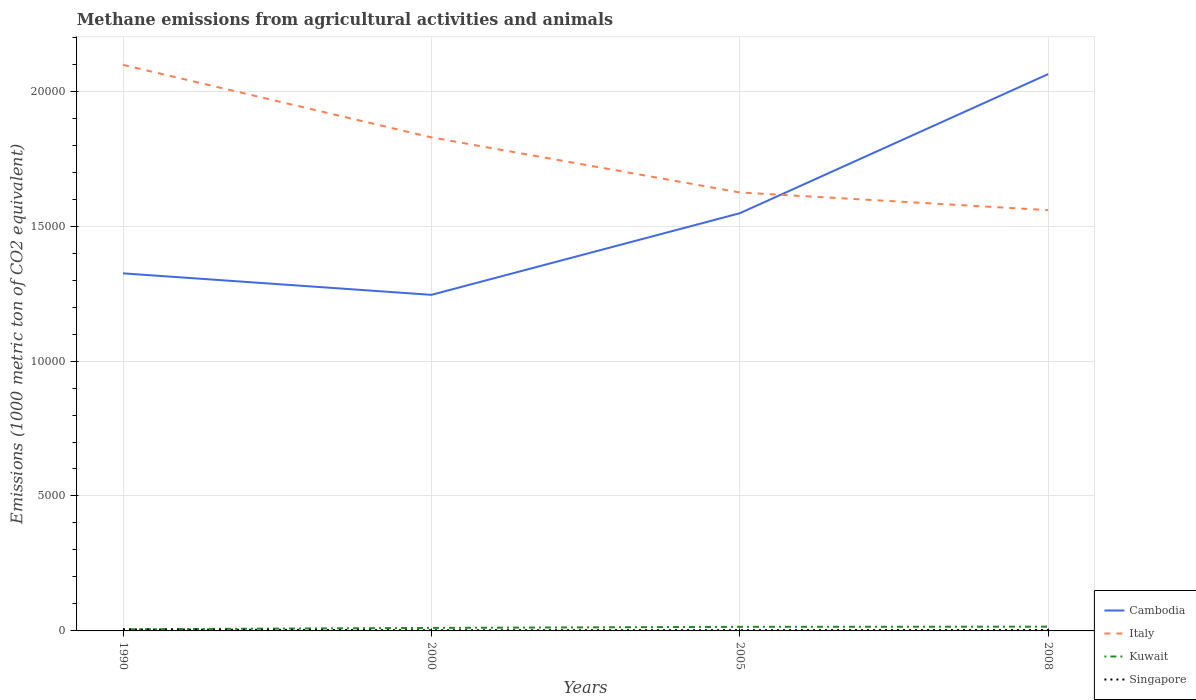How many different coloured lines are there?
Provide a succinct answer. 4. Is the number of lines equal to the number of legend labels?
Provide a succinct answer. Yes. Across all years, what is the maximum amount of methane emitted in Cambodia?
Give a very brief answer. 1.25e+04. What is the total amount of methane emitted in Kuwait in the graph?
Your answer should be very brief. -46.4. What is the difference between the highest and the second highest amount of methane emitted in Italy?
Your answer should be very brief. 5383.9. What is the difference between the highest and the lowest amount of methane emitted in Italy?
Give a very brief answer. 2. Is the amount of methane emitted in Cambodia strictly greater than the amount of methane emitted in Italy over the years?
Offer a very short reply. No. How many lines are there?
Provide a succinct answer. 4. How many years are there in the graph?
Your answer should be compact. 4. Does the graph contain any zero values?
Your answer should be compact. No. How many legend labels are there?
Provide a succinct answer. 4. How are the legend labels stacked?
Keep it short and to the point. Vertical. What is the title of the graph?
Ensure brevity in your answer.  Methane emissions from agricultural activities and animals. Does "Antigua and Barbuda" appear as one of the legend labels in the graph?
Make the answer very short. No. What is the label or title of the X-axis?
Your response must be concise. Years. What is the label or title of the Y-axis?
Offer a very short reply. Emissions (1000 metric ton of CO2 equivalent). What is the Emissions (1000 metric ton of CO2 equivalent) in Cambodia in 1990?
Your answer should be compact. 1.32e+04. What is the Emissions (1000 metric ton of CO2 equivalent) of Italy in 1990?
Keep it short and to the point. 2.10e+04. What is the Emissions (1000 metric ton of CO2 equivalent) of Kuwait in 1990?
Offer a terse response. 60.5. What is the Emissions (1000 metric ton of CO2 equivalent) in Singapore in 1990?
Provide a short and direct response. 55.6. What is the Emissions (1000 metric ton of CO2 equivalent) in Cambodia in 2000?
Your answer should be very brief. 1.25e+04. What is the Emissions (1000 metric ton of CO2 equivalent) in Italy in 2000?
Your answer should be compact. 1.83e+04. What is the Emissions (1000 metric ton of CO2 equivalent) in Kuwait in 2000?
Make the answer very short. 111.6. What is the Emissions (1000 metric ton of CO2 equivalent) in Singapore in 2000?
Keep it short and to the point. 24.4. What is the Emissions (1000 metric ton of CO2 equivalent) in Cambodia in 2005?
Give a very brief answer. 1.55e+04. What is the Emissions (1000 metric ton of CO2 equivalent) of Italy in 2005?
Ensure brevity in your answer.  1.62e+04. What is the Emissions (1000 metric ton of CO2 equivalent) in Kuwait in 2005?
Your response must be concise. 151.9. What is the Emissions (1000 metric ton of CO2 equivalent) of Singapore in 2005?
Your answer should be compact. 28.4. What is the Emissions (1000 metric ton of CO2 equivalent) in Cambodia in 2008?
Your answer should be compact. 2.06e+04. What is the Emissions (1000 metric ton of CO2 equivalent) of Italy in 2008?
Offer a very short reply. 1.56e+04. What is the Emissions (1000 metric ton of CO2 equivalent) of Kuwait in 2008?
Give a very brief answer. 158. What is the Emissions (1000 metric ton of CO2 equivalent) of Singapore in 2008?
Keep it short and to the point. 32.8. Across all years, what is the maximum Emissions (1000 metric ton of CO2 equivalent) of Cambodia?
Keep it short and to the point. 2.06e+04. Across all years, what is the maximum Emissions (1000 metric ton of CO2 equivalent) of Italy?
Your answer should be very brief. 2.10e+04. Across all years, what is the maximum Emissions (1000 metric ton of CO2 equivalent) of Kuwait?
Provide a short and direct response. 158. Across all years, what is the maximum Emissions (1000 metric ton of CO2 equivalent) of Singapore?
Keep it short and to the point. 55.6. Across all years, what is the minimum Emissions (1000 metric ton of CO2 equivalent) of Cambodia?
Offer a terse response. 1.25e+04. Across all years, what is the minimum Emissions (1000 metric ton of CO2 equivalent) of Italy?
Give a very brief answer. 1.56e+04. Across all years, what is the minimum Emissions (1000 metric ton of CO2 equivalent) of Kuwait?
Offer a very short reply. 60.5. Across all years, what is the minimum Emissions (1000 metric ton of CO2 equivalent) of Singapore?
Your response must be concise. 24.4. What is the total Emissions (1000 metric ton of CO2 equivalent) in Cambodia in the graph?
Your response must be concise. 6.18e+04. What is the total Emissions (1000 metric ton of CO2 equivalent) in Italy in the graph?
Your answer should be very brief. 7.11e+04. What is the total Emissions (1000 metric ton of CO2 equivalent) in Kuwait in the graph?
Your response must be concise. 482. What is the total Emissions (1000 metric ton of CO2 equivalent) of Singapore in the graph?
Make the answer very short. 141.2. What is the difference between the Emissions (1000 metric ton of CO2 equivalent) of Cambodia in 1990 and that in 2000?
Your answer should be compact. 796.5. What is the difference between the Emissions (1000 metric ton of CO2 equivalent) in Italy in 1990 and that in 2000?
Offer a terse response. 2687.3. What is the difference between the Emissions (1000 metric ton of CO2 equivalent) of Kuwait in 1990 and that in 2000?
Ensure brevity in your answer.  -51.1. What is the difference between the Emissions (1000 metric ton of CO2 equivalent) of Singapore in 1990 and that in 2000?
Your answer should be very brief. 31.2. What is the difference between the Emissions (1000 metric ton of CO2 equivalent) of Cambodia in 1990 and that in 2005?
Provide a succinct answer. -2227.1. What is the difference between the Emissions (1000 metric ton of CO2 equivalent) of Italy in 1990 and that in 2005?
Offer a very short reply. 4727.8. What is the difference between the Emissions (1000 metric ton of CO2 equivalent) in Kuwait in 1990 and that in 2005?
Your answer should be compact. -91.4. What is the difference between the Emissions (1000 metric ton of CO2 equivalent) of Singapore in 1990 and that in 2005?
Keep it short and to the point. 27.2. What is the difference between the Emissions (1000 metric ton of CO2 equivalent) of Cambodia in 1990 and that in 2008?
Provide a short and direct response. -7382.4. What is the difference between the Emissions (1000 metric ton of CO2 equivalent) in Italy in 1990 and that in 2008?
Your answer should be compact. 5383.9. What is the difference between the Emissions (1000 metric ton of CO2 equivalent) of Kuwait in 1990 and that in 2008?
Offer a terse response. -97.5. What is the difference between the Emissions (1000 metric ton of CO2 equivalent) of Singapore in 1990 and that in 2008?
Your response must be concise. 22.8. What is the difference between the Emissions (1000 metric ton of CO2 equivalent) in Cambodia in 2000 and that in 2005?
Make the answer very short. -3023.6. What is the difference between the Emissions (1000 metric ton of CO2 equivalent) of Italy in 2000 and that in 2005?
Give a very brief answer. 2040.5. What is the difference between the Emissions (1000 metric ton of CO2 equivalent) in Kuwait in 2000 and that in 2005?
Give a very brief answer. -40.3. What is the difference between the Emissions (1000 metric ton of CO2 equivalent) in Singapore in 2000 and that in 2005?
Make the answer very short. -4. What is the difference between the Emissions (1000 metric ton of CO2 equivalent) of Cambodia in 2000 and that in 2008?
Give a very brief answer. -8178.9. What is the difference between the Emissions (1000 metric ton of CO2 equivalent) of Italy in 2000 and that in 2008?
Your answer should be compact. 2696.6. What is the difference between the Emissions (1000 metric ton of CO2 equivalent) of Kuwait in 2000 and that in 2008?
Make the answer very short. -46.4. What is the difference between the Emissions (1000 metric ton of CO2 equivalent) in Cambodia in 2005 and that in 2008?
Ensure brevity in your answer.  -5155.3. What is the difference between the Emissions (1000 metric ton of CO2 equivalent) in Italy in 2005 and that in 2008?
Offer a very short reply. 656.1. What is the difference between the Emissions (1000 metric ton of CO2 equivalent) in Cambodia in 1990 and the Emissions (1000 metric ton of CO2 equivalent) in Italy in 2000?
Keep it short and to the point. -5038.3. What is the difference between the Emissions (1000 metric ton of CO2 equivalent) of Cambodia in 1990 and the Emissions (1000 metric ton of CO2 equivalent) of Kuwait in 2000?
Offer a terse response. 1.31e+04. What is the difference between the Emissions (1000 metric ton of CO2 equivalent) in Cambodia in 1990 and the Emissions (1000 metric ton of CO2 equivalent) in Singapore in 2000?
Give a very brief answer. 1.32e+04. What is the difference between the Emissions (1000 metric ton of CO2 equivalent) in Italy in 1990 and the Emissions (1000 metric ton of CO2 equivalent) in Kuwait in 2000?
Your answer should be compact. 2.09e+04. What is the difference between the Emissions (1000 metric ton of CO2 equivalent) of Italy in 1990 and the Emissions (1000 metric ton of CO2 equivalent) of Singapore in 2000?
Give a very brief answer. 2.10e+04. What is the difference between the Emissions (1000 metric ton of CO2 equivalent) of Kuwait in 1990 and the Emissions (1000 metric ton of CO2 equivalent) of Singapore in 2000?
Offer a very short reply. 36.1. What is the difference between the Emissions (1000 metric ton of CO2 equivalent) of Cambodia in 1990 and the Emissions (1000 metric ton of CO2 equivalent) of Italy in 2005?
Your answer should be very brief. -2997.8. What is the difference between the Emissions (1000 metric ton of CO2 equivalent) in Cambodia in 1990 and the Emissions (1000 metric ton of CO2 equivalent) in Kuwait in 2005?
Give a very brief answer. 1.31e+04. What is the difference between the Emissions (1000 metric ton of CO2 equivalent) in Cambodia in 1990 and the Emissions (1000 metric ton of CO2 equivalent) in Singapore in 2005?
Your answer should be very brief. 1.32e+04. What is the difference between the Emissions (1000 metric ton of CO2 equivalent) in Italy in 1990 and the Emissions (1000 metric ton of CO2 equivalent) in Kuwait in 2005?
Offer a very short reply. 2.08e+04. What is the difference between the Emissions (1000 metric ton of CO2 equivalent) in Italy in 1990 and the Emissions (1000 metric ton of CO2 equivalent) in Singapore in 2005?
Offer a very short reply. 2.09e+04. What is the difference between the Emissions (1000 metric ton of CO2 equivalent) of Kuwait in 1990 and the Emissions (1000 metric ton of CO2 equivalent) of Singapore in 2005?
Offer a terse response. 32.1. What is the difference between the Emissions (1000 metric ton of CO2 equivalent) of Cambodia in 1990 and the Emissions (1000 metric ton of CO2 equivalent) of Italy in 2008?
Your answer should be very brief. -2341.7. What is the difference between the Emissions (1000 metric ton of CO2 equivalent) in Cambodia in 1990 and the Emissions (1000 metric ton of CO2 equivalent) in Kuwait in 2008?
Provide a short and direct response. 1.31e+04. What is the difference between the Emissions (1000 metric ton of CO2 equivalent) in Cambodia in 1990 and the Emissions (1000 metric ton of CO2 equivalent) in Singapore in 2008?
Provide a short and direct response. 1.32e+04. What is the difference between the Emissions (1000 metric ton of CO2 equivalent) of Italy in 1990 and the Emissions (1000 metric ton of CO2 equivalent) of Kuwait in 2008?
Your answer should be compact. 2.08e+04. What is the difference between the Emissions (1000 metric ton of CO2 equivalent) in Italy in 1990 and the Emissions (1000 metric ton of CO2 equivalent) in Singapore in 2008?
Your answer should be compact. 2.09e+04. What is the difference between the Emissions (1000 metric ton of CO2 equivalent) in Kuwait in 1990 and the Emissions (1000 metric ton of CO2 equivalent) in Singapore in 2008?
Your response must be concise. 27.7. What is the difference between the Emissions (1000 metric ton of CO2 equivalent) in Cambodia in 2000 and the Emissions (1000 metric ton of CO2 equivalent) in Italy in 2005?
Provide a short and direct response. -3794.3. What is the difference between the Emissions (1000 metric ton of CO2 equivalent) in Cambodia in 2000 and the Emissions (1000 metric ton of CO2 equivalent) in Kuwait in 2005?
Provide a short and direct response. 1.23e+04. What is the difference between the Emissions (1000 metric ton of CO2 equivalent) in Cambodia in 2000 and the Emissions (1000 metric ton of CO2 equivalent) in Singapore in 2005?
Offer a very short reply. 1.24e+04. What is the difference between the Emissions (1000 metric ton of CO2 equivalent) of Italy in 2000 and the Emissions (1000 metric ton of CO2 equivalent) of Kuwait in 2005?
Ensure brevity in your answer.  1.81e+04. What is the difference between the Emissions (1000 metric ton of CO2 equivalent) in Italy in 2000 and the Emissions (1000 metric ton of CO2 equivalent) in Singapore in 2005?
Ensure brevity in your answer.  1.83e+04. What is the difference between the Emissions (1000 metric ton of CO2 equivalent) in Kuwait in 2000 and the Emissions (1000 metric ton of CO2 equivalent) in Singapore in 2005?
Give a very brief answer. 83.2. What is the difference between the Emissions (1000 metric ton of CO2 equivalent) of Cambodia in 2000 and the Emissions (1000 metric ton of CO2 equivalent) of Italy in 2008?
Provide a short and direct response. -3138.2. What is the difference between the Emissions (1000 metric ton of CO2 equivalent) of Cambodia in 2000 and the Emissions (1000 metric ton of CO2 equivalent) of Kuwait in 2008?
Your response must be concise. 1.23e+04. What is the difference between the Emissions (1000 metric ton of CO2 equivalent) of Cambodia in 2000 and the Emissions (1000 metric ton of CO2 equivalent) of Singapore in 2008?
Provide a succinct answer. 1.24e+04. What is the difference between the Emissions (1000 metric ton of CO2 equivalent) in Italy in 2000 and the Emissions (1000 metric ton of CO2 equivalent) in Kuwait in 2008?
Provide a succinct answer. 1.81e+04. What is the difference between the Emissions (1000 metric ton of CO2 equivalent) of Italy in 2000 and the Emissions (1000 metric ton of CO2 equivalent) of Singapore in 2008?
Offer a very short reply. 1.83e+04. What is the difference between the Emissions (1000 metric ton of CO2 equivalent) of Kuwait in 2000 and the Emissions (1000 metric ton of CO2 equivalent) of Singapore in 2008?
Make the answer very short. 78.8. What is the difference between the Emissions (1000 metric ton of CO2 equivalent) of Cambodia in 2005 and the Emissions (1000 metric ton of CO2 equivalent) of Italy in 2008?
Give a very brief answer. -114.6. What is the difference between the Emissions (1000 metric ton of CO2 equivalent) in Cambodia in 2005 and the Emissions (1000 metric ton of CO2 equivalent) in Kuwait in 2008?
Offer a very short reply. 1.53e+04. What is the difference between the Emissions (1000 metric ton of CO2 equivalent) in Cambodia in 2005 and the Emissions (1000 metric ton of CO2 equivalent) in Singapore in 2008?
Provide a short and direct response. 1.54e+04. What is the difference between the Emissions (1000 metric ton of CO2 equivalent) of Italy in 2005 and the Emissions (1000 metric ton of CO2 equivalent) of Kuwait in 2008?
Your answer should be very brief. 1.61e+04. What is the difference between the Emissions (1000 metric ton of CO2 equivalent) of Italy in 2005 and the Emissions (1000 metric ton of CO2 equivalent) of Singapore in 2008?
Your answer should be very brief. 1.62e+04. What is the difference between the Emissions (1000 metric ton of CO2 equivalent) of Kuwait in 2005 and the Emissions (1000 metric ton of CO2 equivalent) of Singapore in 2008?
Give a very brief answer. 119.1. What is the average Emissions (1000 metric ton of CO2 equivalent) of Cambodia per year?
Offer a terse response. 1.55e+04. What is the average Emissions (1000 metric ton of CO2 equivalent) of Italy per year?
Your answer should be compact. 1.78e+04. What is the average Emissions (1000 metric ton of CO2 equivalent) of Kuwait per year?
Provide a short and direct response. 120.5. What is the average Emissions (1000 metric ton of CO2 equivalent) of Singapore per year?
Make the answer very short. 35.3. In the year 1990, what is the difference between the Emissions (1000 metric ton of CO2 equivalent) in Cambodia and Emissions (1000 metric ton of CO2 equivalent) in Italy?
Provide a succinct answer. -7725.6. In the year 1990, what is the difference between the Emissions (1000 metric ton of CO2 equivalent) in Cambodia and Emissions (1000 metric ton of CO2 equivalent) in Kuwait?
Keep it short and to the point. 1.32e+04. In the year 1990, what is the difference between the Emissions (1000 metric ton of CO2 equivalent) of Cambodia and Emissions (1000 metric ton of CO2 equivalent) of Singapore?
Provide a succinct answer. 1.32e+04. In the year 1990, what is the difference between the Emissions (1000 metric ton of CO2 equivalent) in Italy and Emissions (1000 metric ton of CO2 equivalent) in Kuwait?
Keep it short and to the point. 2.09e+04. In the year 1990, what is the difference between the Emissions (1000 metric ton of CO2 equivalent) of Italy and Emissions (1000 metric ton of CO2 equivalent) of Singapore?
Keep it short and to the point. 2.09e+04. In the year 2000, what is the difference between the Emissions (1000 metric ton of CO2 equivalent) of Cambodia and Emissions (1000 metric ton of CO2 equivalent) of Italy?
Your response must be concise. -5834.8. In the year 2000, what is the difference between the Emissions (1000 metric ton of CO2 equivalent) in Cambodia and Emissions (1000 metric ton of CO2 equivalent) in Kuwait?
Your answer should be compact. 1.23e+04. In the year 2000, what is the difference between the Emissions (1000 metric ton of CO2 equivalent) of Cambodia and Emissions (1000 metric ton of CO2 equivalent) of Singapore?
Provide a short and direct response. 1.24e+04. In the year 2000, what is the difference between the Emissions (1000 metric ton of CO2 equivalent) of Italy and Emissions (1000 metric ton of CO2 equivalent) of Kuwait?
Your answer should be very brief. 1.82e+04. In the year 2000, what is the difference between the Emissions (1000 metric ton of CO2 equivalent) in Italy and Emissions (1000 metric ton of CO2 equivalent) in Singapore?
Your answer should be compact. 1.83e+04. In the year 2000, what is the difference between the Emissions (1000 metric ton of CO2 equivalent) in Kuwait and Emissions (1000 metric ton of CO2 equivalent) in Singapore?
Give a very brief answer. 87.2. In the year 2005, what is the difference between the Emissions (1000 metric ton of CO2 equivalent) in Cambodia and Emissions (1000 metric ton of CO2 equivalent) in Italy?
Ensure brevity in your answer.  -770.7. In the year 2005, what is the difference between the Emissions (1000 metric ton of CO2 equivalent) of Cambodia and Emissions (1000 metric ton of CO2 equivalent) of Kuwait?
Give a very brief answer. 1.53e+04. In the year 2005, what is the difference between the Emissions (1000 metric ton of CO2 equivalent) of Cambodia and Emissions (1000 metric ton of CO2 equivalent) of Singapore?
Give a very brief answer. 1.54e+04. In the year 2005, what is the difference between the Emissions (1000 metric ton of CO2 equivalent) of Italy and Emissions (1000 metric ton of CO2 equivalent) of Kuwait?
Your response must be concise. 1.61e+04. In the year 2005, what is the difference between the Emissions (1000 metric ton of CO2 equivalent) of Italy and Emissions (1000 metric ton of CO2 equivalent) of Singapore?
Your response must be concise. 1.62e+04. In the year 2005, what is the difference between the Emissions (1000 metric ton of CO2 equivalent) of Kuwait and Emissions (1000 metric ton of CO2 equivalent) of Singapore?
Your answer should be very brief. 123.5. In the year 2008, what is the difference between the Emissions (1000 metric ton of CO2 equivalent) in Cambodia and Emissions (1000 metric ton of CO2 equivalent) in Italy?
Make the answer very short. 5040.7. In the year 2008, what is the difference between the Emissions (1000 metric ton of CO2 equivalent) in Cambodia and Emissions (1000 metric ton of CO2 equivalent) in Kuwait?
Offer a terse response. 2.05e+04. In the year 2008, what is the difference between the Emissions (1000 metric ton of CO2 equivalent) in Cambodia and Emissions (1000 metric ton of CO2 equivalent) in Singapore?
Your answer should be compact. 2.06e+04. In the year 2008, what is the difference between the Emissions (1000 metric ton of CO2 equivalent) of Italy and Emissions (1000 metric ton of CO2 equivalent) of Kuwait?
Your answer should be very brief. 1.54e+04. In the year 2008, what is the difference between the Emissions (1000 metric ton of CO2 equivalent) in Italy and Emissions (1000 metric ton of CO2 equivalent) in Singapore?
Provide a short and direct response. 1.56e+04. In the year 2008, what is the difference between the Emissions (1000 metric ton of CO2 equivalent) of Kuwait and Emissions (1000 metric ton of CO2 equivalent) of Singapore?
Provide a succinct answer. 125.2. What is the ratio of the Emissions (1000 metric ton of CO2 equivalent) of Cambodia in 1990 to that in 2000?
Offer a terse response. 1.06. What is the ratio of the Emissions (1000 metric ton of CO2 equivalent) of Italy in 1990 to that in 2000?
Provide a short and direct response. 1.15. What is the ratio of the Emissions (1000 metric ton of CO2 equivalent) in Kuwait in 1990 to that in 2000?
Offer a very short reply. 0.54. What is the ratio of the Emissions (1000 metric ton of CO2 equivalent) in Singapore in 1990 to that in 2000?
Your answer should be very brief. 2.28. What is the ratio of the Emissions (1000 metric ton of CO2 equivalent) of Cambodia in 1990 to that in 2005?
Your response must be concise. 0.86. What is the ratio of the Emissions (1000 metric ton of CO2 equivalent) of Italy in 1990 to that in 2005?
Provide a short and direct response. 1.29. What is the ratio of the Emissions (1000 metric ton of CO2 equivalent) of Kuwait in 1990 to that in 2005?
Keep it short and to the point. 0.4. What is the ratio of the Emissions (1000 metric ton of CO2 equivalent) in Singapore in 1990 to that in 2005?
Offer a terse response. 1.96. What is the ratio of the Emissions (1000 metric ton of CO2 equivalent) in Cambodia in 1990 to that in 2008?
Make the answer very short. 0.64. What is the ratio of the Emissions (1000 metric ton of CO2 equivalent) of Italy in 1990 to that in 2008?
Provide a succinct answer. 1.35. What is the ratio of the Emissions (1000 metric ton of CO2 equivalent) of Kuwait in 1990 to that in 2008?
Give a very brief answer. 0.38. What is the ratio of the Emissions (1000 metric ton of CO2 equivalent) of Singapore in 1990 to that in 2008?
Keep it short and to the point. 1.7. What is the ratio of the Emissions (1000 metric ton of CO2 equivalent) of Cambodia in 2000 to that in 2005?
Provide a succinct answer. 0.8. What is the ratio of the Emissions (1000 metric ton of CO2 equivalent) in Italy in 2000 to that in 2005?
Offer a terse response. 1.13. What is the ratio of the Emissions (1000 metric ton of CO2 equivalent) in Kuwait in 2000 to that in 2005?
Your answer should be very brief. 0.73. What is the ratio of the Emissions (1000 metric ton of CO2 equivalent) of Singapore in 2000 to that in 2005?
Your response must be concise. 0.86. What is the ratio of the Emissions (1000 metric ton of CO2 equivalent) in Cambodia in 2000 to that in 2008?
Offer a very short reply. 0.6. What is the ratio of the Emissions (1000 metric ton of CO2 equivalent) of Italy in 2000 to that in 2008?
Your answer should be very brief. 1.17. What is the ratio of the Emissions (1000 metric ton of CO2 equivalent) in Kuwait in 2000 to that in 2008?
Ensure brevity in your answer.  0.71. What is the ratio of the Emissions (1000 metric ton of CO2 equivalent) of Singapore in 2000 to that in 2008?
Your answer should be very brief. 0.74. What is the ratio of the Emissions (1000 metric ton of CO2 equivalent) in Cambodia in 2005 to that in 2008?
Keep it short and to the point. 0.75. What is the ratio of the Emissions (1000 metric ton of CO2 equivalent) of Italy in 2005 to that in 2008?
Ensure brevity in your answer.  1.04. What is the ratio of the Emissions (1000 metric ton of CO2 equivalent) in Kuwait in 2005 to that in 2008?
Make the answer very short. 0.96. What is the ratio of the Emissions (1000 metric ton of CO2 equivalent) of Singapore in 2005 to that in 2008?
Provide a short and direct response. 0.87. What is the difference between the highest and the second highest Emissions (1000 metric ton of CO2 equivalent) of Cambodia?
Keep it short and to the point. 5155.3. What is the difference between the highest and the second highest Emissions (1000 metric ton of CO2 equivalent) of Italy?
Give a very brief answer. 2687.3. What is the difference between the highest and the second highest Emissions (1000 metric ton of CO2 equivalent) in Kuwait?
Provide a short and direct response. 6.1. What is the difference between the highest and the second highest Emissions (1000 metric ton of CO2 equivalent) of Singapore?
Offer a terse response. 22.8. What is the difference between the highest and the lowest Emissions (1000 metric ton of CO2 equivalent) in Cambodia?
Offer a very short reply. 8178.9. What is the difference between the highest and the lowest Emissions (1000 metric ton of CO2 equivalent) in Italy?
Your answer should be very brief. 5383.9. What is the difference between the highest and the lowest Emissions (1000 metric ton of CO2 equivalent) in Kuwait?
Offer a very short reply. 97.5. What is the difference between the highest and the lowest Emissions (1000 metric ton of CO2 equivalent) of Singapore?
Provide a succinct answer. 31.2. 